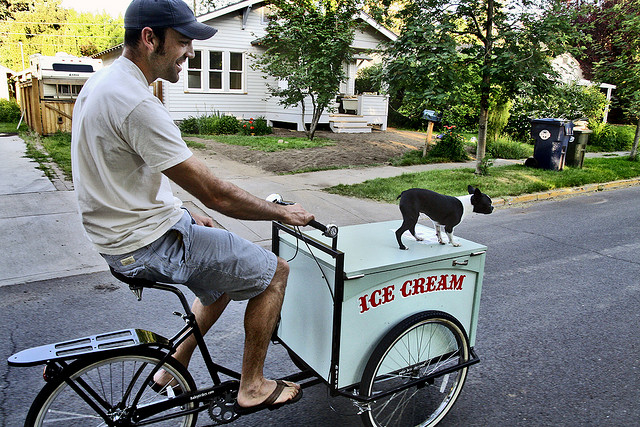Please extract the text content from this image. ICE CREAM 